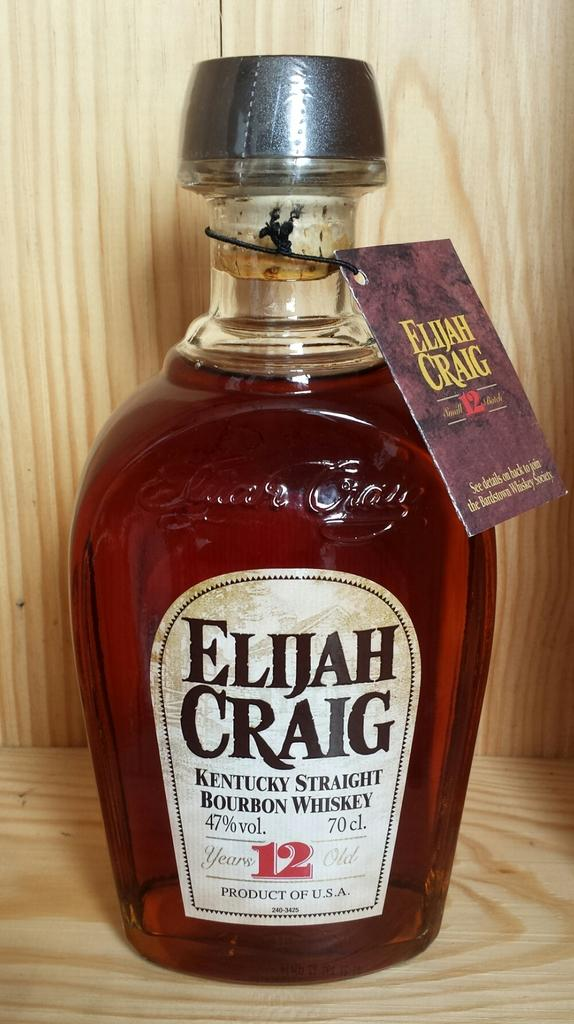Provide a one-sentence caption for the provided image. A full bottle of bourbon whiskey is still sealed with a hang tag. 